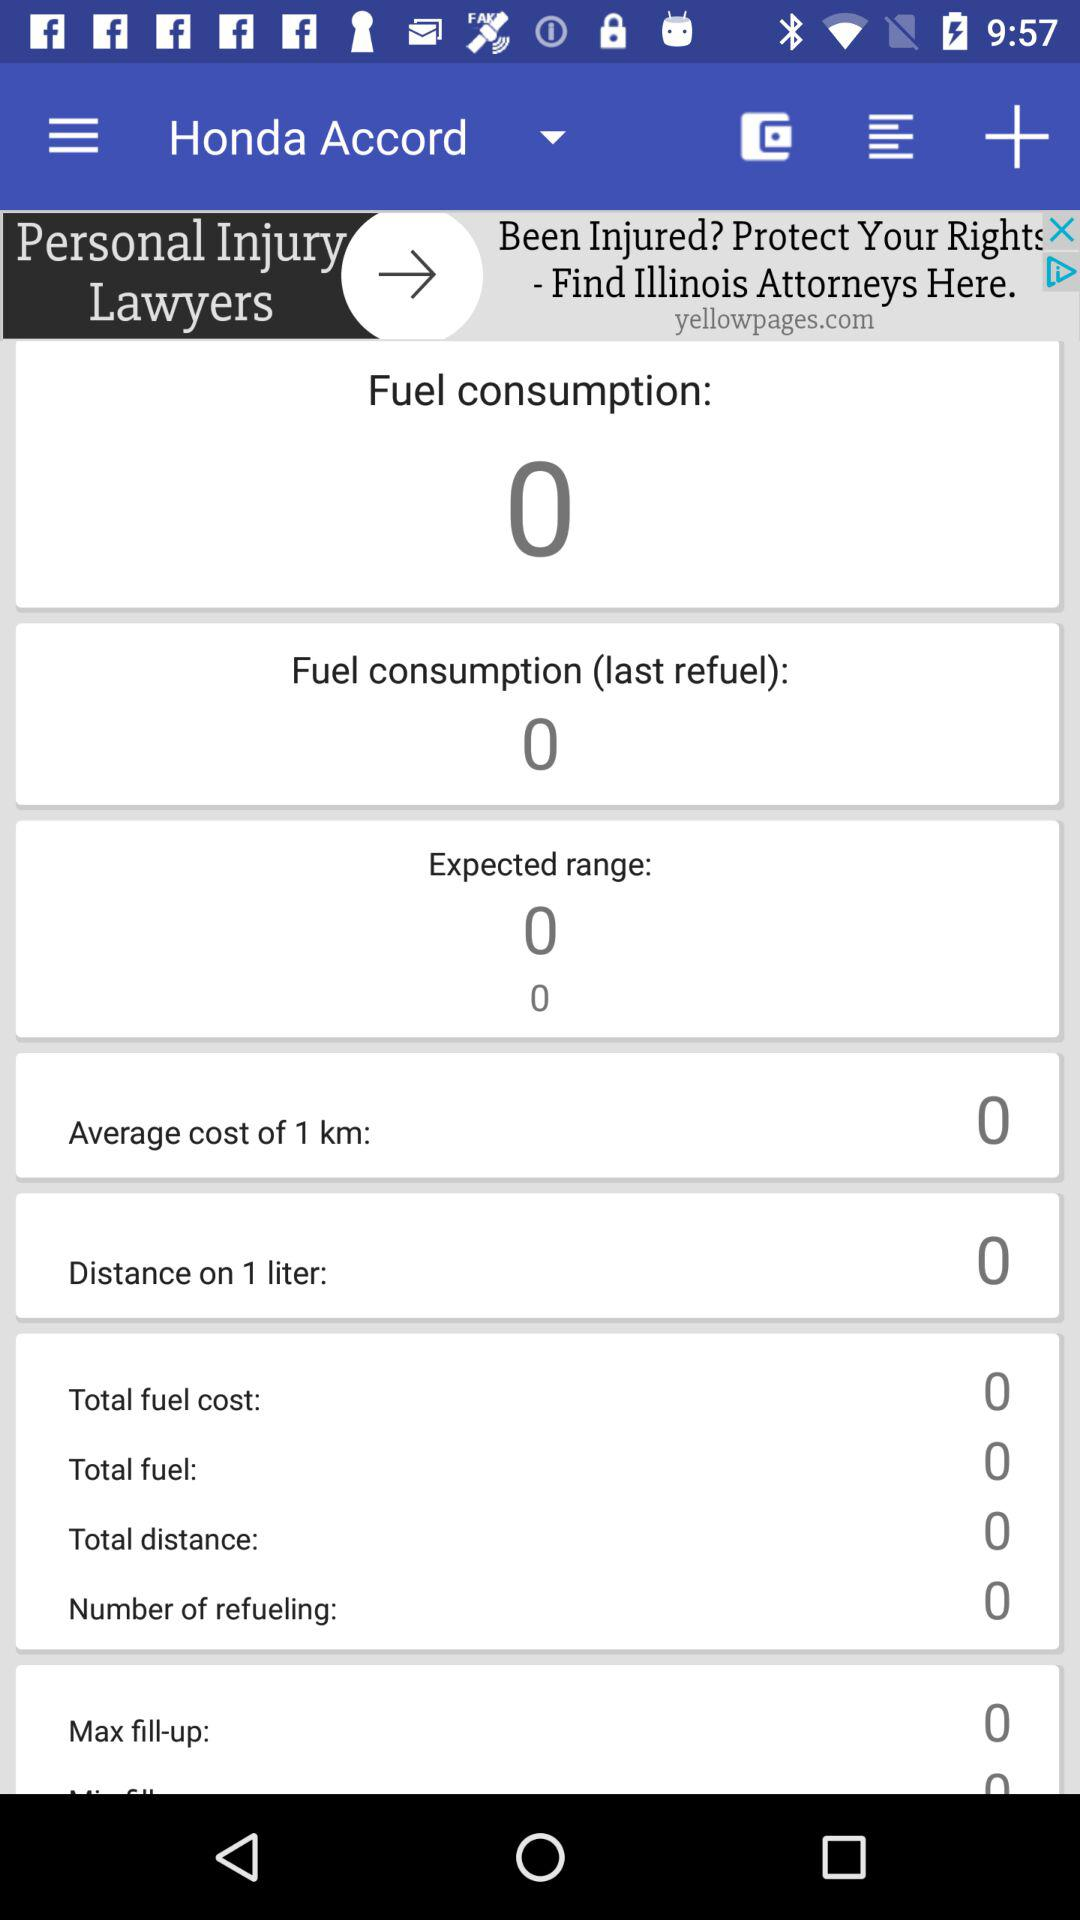How much is the "Distance on 1 liter"? The "Distance on 1 liter" is 0. 